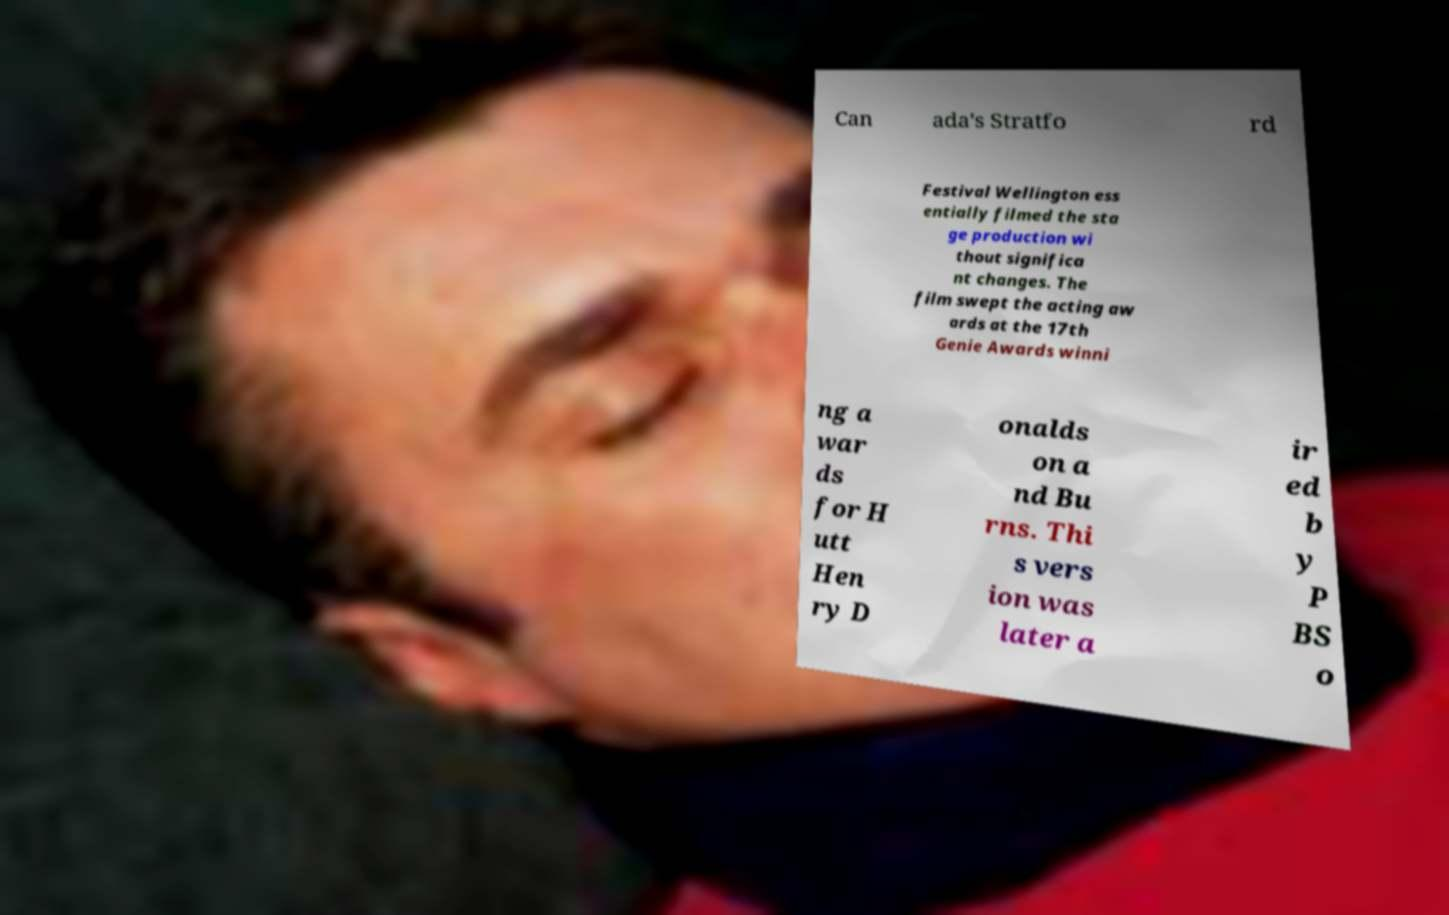What messages or text are displayed in this image? I need them in a readable, typed format. Can ada's Stratfo rd Festival Wellington ess entially filmed the sta ge production wi thout significa nt changes. The film swept the acting aw ards at the 17th Genie Awards winni ng a war ds for H utt Hen ry D onalds on a nd Bu rns. Thi s vers ion was later a ir ed b y P BS o 